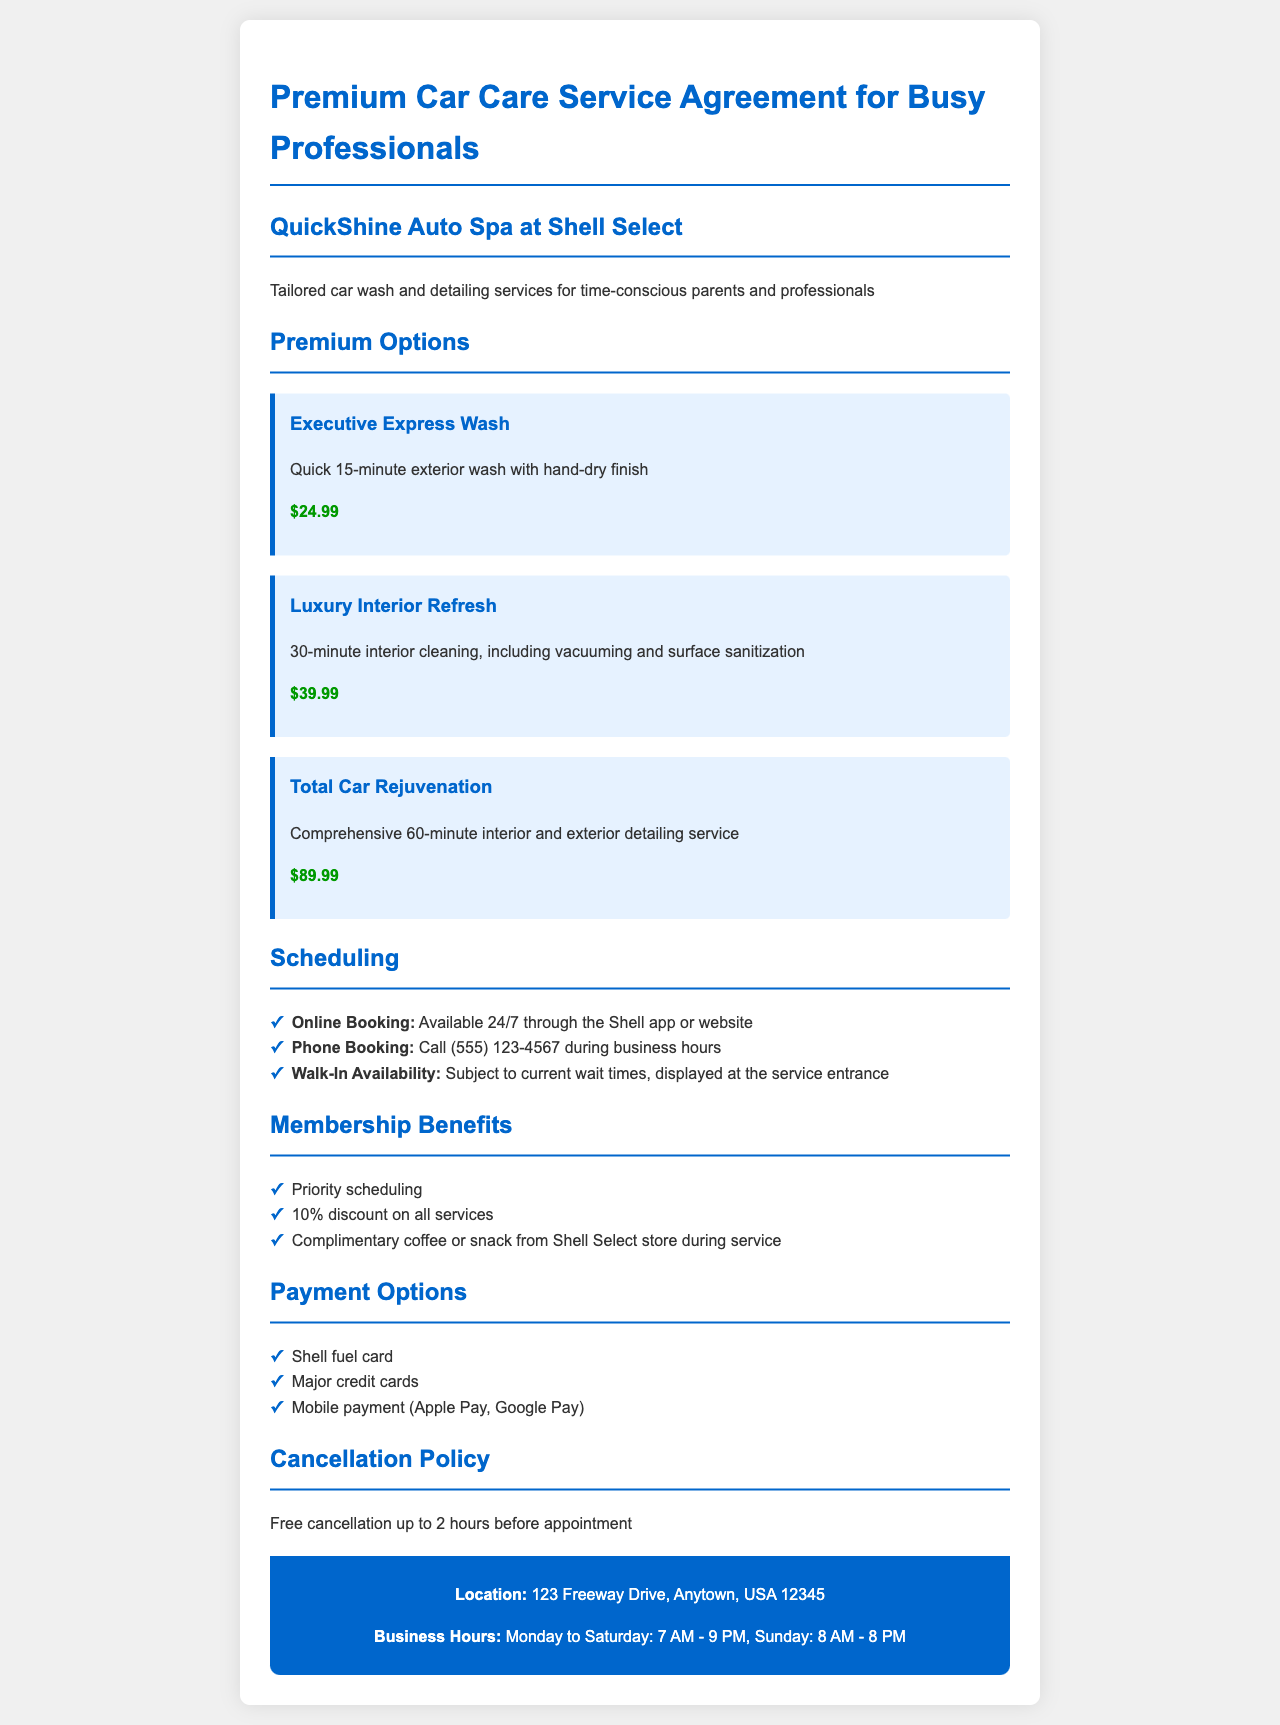What is the price of the Executive Express Wash? The price for the Executive Express Wash is stated in the document as $24.99.
Answer: $24.99 How long does the Total Car Rejuvenation service take? The document specifies that the Total Car Rejuvenation service takes a comprehensive 60 minutes.
Answer: 60 minutes What are the business hours on Sunday? The document lists the Sunday business hours as 8 AM to 8 PM.
Answer: 8 AM - 8 PM What is the cancellation policy? The document states that free cancellation is allowed up to 2 hours before the appointment.
Answer: Free cancellation up to 2 hours before appointment Which phone number can be called for booking? The document provides a phone number for booking services, which is (555) 123-4567.
Answer: (555) 123-4567 What is included in the membership benefits? The document outlines the membership benefits, including priority scheduling and a 10% discount on all services.
Answer: Priority scheduling, 10% discount How can appointments be booked? The document lists online booking, phone booking, and walk-in availability as options for scheduling appointments.
Answer: Online, Phone, Walk-In What is the price of the Luxury Interior Refresh? The document specifies that the Luxury Interior Refresh costs $39.99.
Answer: $39.99 